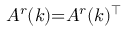Convert formula to latex. <formula><loc_0><loc_0><loc_500><loc_500>A ^ { r } ( k ) { = } A ^ { r } ( k ) ^ { \top }</formula> 